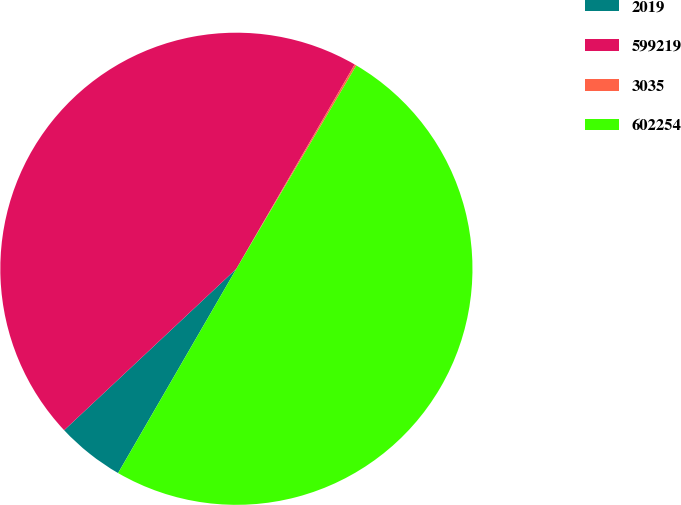Convert chart. <chart><loc_0><loc_0><loc_500><loc_500><pie_chart><fcel>2019<fcel>599219<fcel>3035<fcel>602254<nl><fcel>4.66%<fcel>45.34%<fcel>0.13%<fcel>49.87%<nl></chart> 